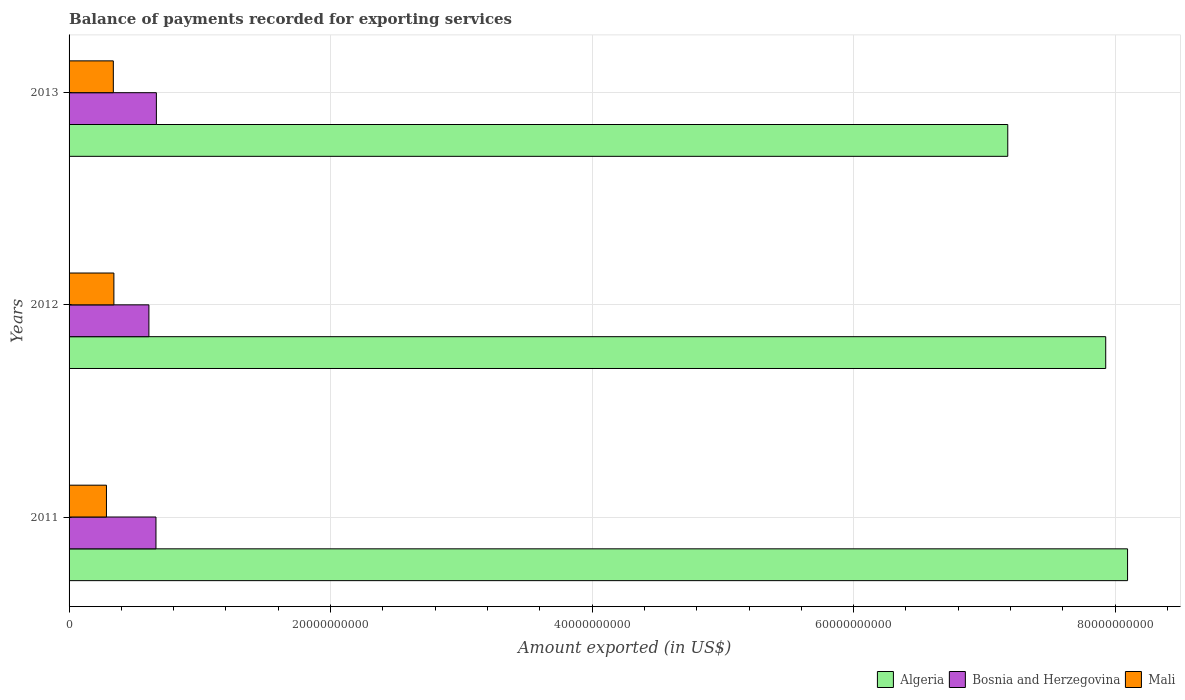How many different coloured bars are there?
Keep it short and to the point. 3. What is the amount exported in Mali in 2012?
Provide a short and direct response. 3.43e+09. Across all years, what is the maximum amount exported in Algeria?
Your response must be concise. 8.10e+1. Across all years, what is the minimum amount exported in Algeria?
Provide a short and direct response. 7.18e+1. In which year was the amount exported in Mali maximum?
Make the answer very short. 2012. In which year was the amount exported in Mali minimum?
Give a very brief answer. 2011. What is the total amount exported in Bosnia and Herzegovina in the graph?
Offer a terse response. 1.94e+1. What is the difference between the amount exported in Mali in 2011 and that in 2012?
Your answer should be compact. -5.68e+08. What is the difference between the amount exported in Algeria in 2013 and the amount exported in Bosnia and Herzegovina in 2012?
Keep it short and to the point. 6.57e+1. What is the average amount exported in Algeria per year?
Your answer should be very brief. 7.73e+1. In the year 2011, what is the difference between the amount exported in Mali and amount exported in Bosnia and Herzegovina?
Provide a short and direct response. -3.79e+09. What is the ratio of the amount exported in Bosnia and Herzegovina in 2012 to that in 2013?
Make the answer very short. 0.91. What is the difference between the highest and the second highest amount exported in Bosnia and Herzegovina?
Keep it short and to the point. 3.09e+07. What is the difference between the highest and the lowest amount exported in Algeria?
Provide a short and direct response. 9.16e+09. In how many years, is the amount exported in Mali greater than the average amount exported in Mali taken over all years?
Your answer should be very brief. 2. What does the 3rd bar from the top in 2013 represents?
Keep it short and to the point. Algeria. What does the 1st bar from the bottom in 2012 represents?
Give a very brief answer. Algeria. How many years are there in the graph?
Give a very brief answer. 3. What is the difference between two consecutive major ticks on the X-axis?
Your answer should be compact. 2.00e+1. Are the values on the major ticks of X-axis written in scientific E-notation?
Your response must be concise. No. Does the graph contain any zero values?
Keep it short and to the point. No. How are the legend labels stacked?
Make the answer very short. Horizontal. What is the title of the graph?
Offer a terse response. Balance of payments recorded for exporting services. What is the label or title of the X-axis?
Keep it short and to the point. Amount exported (in US$). What is the Amount exported (in US$) in Algeria in 2011?
Ensure brevity in your answer.  8.10e+1. What is the Amount exported (in US$) in Bosnia and Herzegovina in 2011?
Keep it short and to the point. 6.65e+09. What is the Amount exported (in US$) in Mali in 2011?
Your response must be concise. 2.86e+09. What is the Amount exported (in US$) of Algeria in 2012?
Your response must be concise. 7.93e+1. What is the Amount exported (in US$) in Bosnia and Herzegovina in 2012?
Make the answer very short. 6.11e+09. What is the Amount exported (in US$) in Mali in 2012?
Ensure brevity in your answer.  3.43e+09. What is the Amount exported (in US$) in Algeria in 2013?
Make the answer very short. 7.18e+1. What is the Amount exported (in US$) in Bosnia and Herzegovina in 2013?
Offer a terse response. 6.68e+09. What is the Amount exported (in US$) in Mali in 2013?
Make the answer very short. 3.38e+09. Across all years, what is the maximum Amount exported (in US$) of Algeria?
Make the answer very short. 8.10e+1. Across all years, what is the maximum Amount exported (in US$) of Bosnia and Herzegovina?
Your answer should be compact. 6.68e+09. Across all years, what is the maximum Amount exported (in US$) of Mali?
Provide a succinct answer. 3.43e+09. Across all years, what is the minimum Amount exported (in US$) of Algeria?
Keep it short and to the point. 7.18e+1. Across all years, what is the minimum Amount exported (in US$) of Bosnia and Herzegovina?
Your answer should be very brief. 6.11e+09. Across all years, what is the minimum Amount exported (in US$) of Mali?
Your response must be concise. 2.86e+09. What is the total Amount exported (in US$) in Algeria in the graph?
Offer a very short reply. 2.32e+11. What is the total Amount exported (in US$) in Bosnia and Herzegovina in the graph?
Your answer should be compact. 1.94e+1. What is the total Amount exported (in US$) of Mali in the graph?
Offer a very short reply. 9.67e+09. What is the difference between the Amount exported (in US$) of Algeria in 2011 and that in 2012?
Provide a succinct answer. 1.67e+09. What is the difference between the Amount exported (in US$) of Bosnia and Herzegovina in 2011 and that in 2012?
Your answer should be compact. 5.40e+08. What is the difference between the Amount exported (in US$) in Mali in 2011 and that in 2012?
Ensure brevity in your answer.  -5.68e+08. What is the difference between the Amount exported (in US$) of Algeria in 2011 and that in 2013?
Ensure brevity in your answer.  9.16e+09. What is the difference between the Amount exported (in US$) of Bosnia and Herzegovina in 2011 and that in 2013?
Make the answer very short. -3.09e+07. What is the difference between the Amount exported (in US$) in Mali in 2011 and that in 2013?
Make the answer very short. -5.25e+08. What is the difference between the Amount exported (in US$) of Algeria in 2012 and that in 2013?
Your answer should be compact. 7.49e+09. What is the difference between the Amount exported (in US$) of Bosnia and Herzegovina in 2012 and that in 2013?
Provide a short and direct response. -5.71e+08. What is the difference between the Amount exported (in US$) of Mali in 2012 and that in 2013?
Give a very brief answer. 4.31e+07. What is the difference between the Amount exported (in US$) of Algeria in 2011 and the Amount exported (in US$) of Bosnia and Herzegovina in 2012?
Give a very brief answer. 7.48e+1. What is the difference between the Amount exported (in US$) of Algeria in 2011 and the Amount exported (in US$) of Mali in 2012?
Keep it short and to the point. 7.75e+1. What is the difference between the Amount exported (in US$) in Bosnia and Herzegovina in 2011 and the Amount exported (in US$) in Mali in 2012?
Provide a short and direct response. 3.22e+09. What is the difference between the Amount exported (in US$) of Algeria in 2011 and the Amount exported (in US$) of Bosnia and Herzegovina in 2013?
Your answer should be compact. 7.43e+1. What is the difference between the Amount exported (in US$) of Algeria in 2011 and the Amount exported (in US$) of Mali in 2013?
Provide a succinct answer. 7.76e+1. What is the difference between the Amount exported (in US$) of Bosnia and Herzegovina in 2011 and the Amount exported (in US$) of Mali in 2013?
Offer a terse response. 3.26e+09. What is the difference between the Amount exported (in US$) of Algeria in 2012 and the Amount exported (in US$) of Bosnia and Herzegovina in 2013?
Your answer should be very brief. 7.26e+1. What is the difference between the Amount exported (in US$) in Algeria in 2012 and the Amount exported (in US$) in Mali in 2013?
Your response must be concise. 7.59e+1. What is the difference between the Amount exported (in US$) in Bosnia and Herzegovina in 2012 and the Amount exported (in US$) in Mali in 2013?
Keep it short and to the point. 2.72e+09. What is the average Amount exported (in US$) in Algeria per year?
Your answer should be compact. 7.73e+1. What is the average Amount exported (in US$) in Bosnia and Herzegovina per year?
Provide a succinct answer. 6.48e+09. What is the average Amount exported (in US$) in Mali per year?
Provide a short and direct response. 3.22e+09. In the year 2011, what is the difference between the Amount exported (in US$) in Algeria and Amount exported (in US$) in Bosnia and Herzegovina?
Offer a very short reply. 7.43e+1. In the year 2011, what is the difference between the Amount exported (in US$) in Algeria and Amount exported (in US$) in Mali?
Make the answer very short. 7.81e+1. In the year 2011, what is the difference between the Amount exported (in US$) in Bosnia and Herzegovina and Amount exported (in US$) in Mali?
Keep it short and to the point. 3.79e+09. In the year 2012, what is the difference between the Amount exported (in US$) of Algeria and Amount exported (in US$) of Bosnia and Herzegovina?
Your answer should be compact. 7.32e+1. In the year 2012, what is the difference between the Amount exported (in US$) in Algeria and Amount exported (in US$) in Mali?
Provide a succinct answer. 7.59e+1. In the year 2012, what is the difference between the Amount exported (in US$) in Bosnia and Herzegovina and Amount exported (in US$) in Mali?
Offer a terse response. 2.68e+09. In the year 2013, what is the difference between the Amount exported (in US$) of Algeria and Amount exported (in US$) of Bosnia and Herzegovina?
Keep it short and to the point. 6.51e+1. In the year 2013, what is the difference between the Amount exported (in US$) in Algeria and Amount exported (in US$) in Mali?
Give a very brief answer. 6.84e+1. In the year 2013, what is the difference between the Amount exported (in US$) in Bosnia and Herzegovina and Amount exported (in US$) in Mali?
Ensure brevity in your answer.  3.29e+09. What is the ratio of the Amount exported (in US$) of Algeria in 2011 to that in 2012?
Provide a short and direct response. 1.02. What is the ratio of the Amount exported (in US$) in Bosnia and Herzegovina in 2011 to that in 2012?
Ensure brevity in your answer.  1.09. What is the ratio of the Amount exported (in US$) of Mali in 2011 to that in 2012?
Offer a very short reply. 0.83. What is the ratio of the Amount exported (in US$) of Algeria in 2011 to that in 2013?
Your answer should be compact. 1.13. What is the ratio of the Amount exported (in US$) in Bosnia and Herzegovina in 2011 to that in 2013?
Provide a short and direct response. 1. What is the ratio of the Amount exported (in US$) of Mali in 2011 to that in 2013?
Ensure brevity in your answer.  0.84. What is the ratio of the Amount exported (in US$) of Algeria in 2012 to that in 2013?
Your answer should be compact. 1.1. What is the ratio of the Amount exported (in US$) of Bosnia and Herzegovina in 2012 to that in 2013?
Your response must be concise. 0.91. What is the ratio of the Amount exported (in US$) of Mali in 2012 to that in 2013?
Offer a very short reply. 1.01. What is the difference between the highest and the second highest Amount exported (in US$) of Algeria?
Provide a succinct answer. 1.67e+09. What is the difference between the highest and the second highest Amount exported (in US$) of Bosnia and Herzegovina?
Ensure brevity in your answer.  3.09e+07. What is the difference between the highest and the second highest Amount exported (in US$) of Mali?
Your answer should be very brief. 4.31e+07. What is the difference between the highest and the lowest Amount exported (in US$) in Algeria?
Offer a very short reply. 9.16e+09. What is the difference between the highest and the lowest Amount exported (in US$) in Bosnia and Herzegovina?
Keep it short and to the point. 5.71e+08. What is the difference between the highest and the lowest Amount exported (in US$) of Mali?
Ensure brevity in your answer.  5.68e+08. 